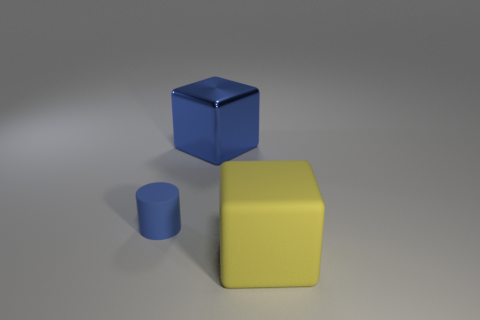How many objects are behind the large matte object and to the right of the blue rubber cylinder? There is one object positioned behind the large, matte yellow cube and to the right of the smaller blue cylinder. It is a blue cube with a clearly visible sheen indicating it's made of a reflective material, possibly plastic or polished metal. 